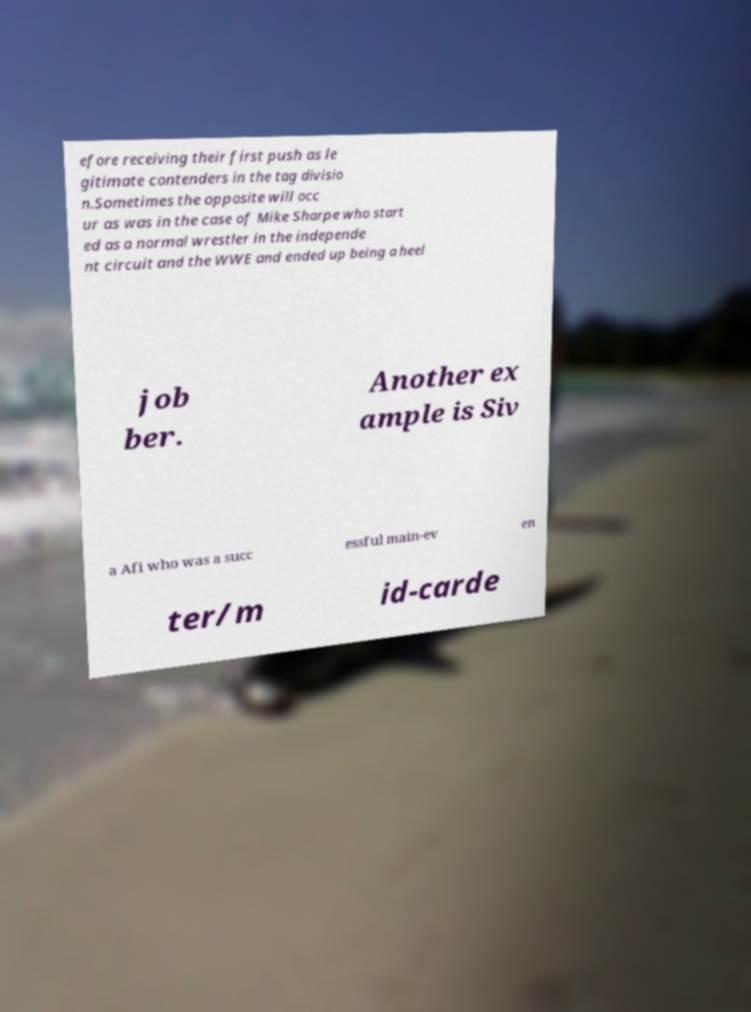Please read and relay the text visible in this image. What does it say? efore receiving their first push as le gitimate contenders in the tag divisio n.Sometimes the opposite will occ ur as was in the case of Mike Sharpe who start ed as a normal wrestler in the independe nt circuit and the WWE and ended up being a heel job ber. Another ex ample is Siv a Afi who was a succ essful main-ev en ter/m id-carde 